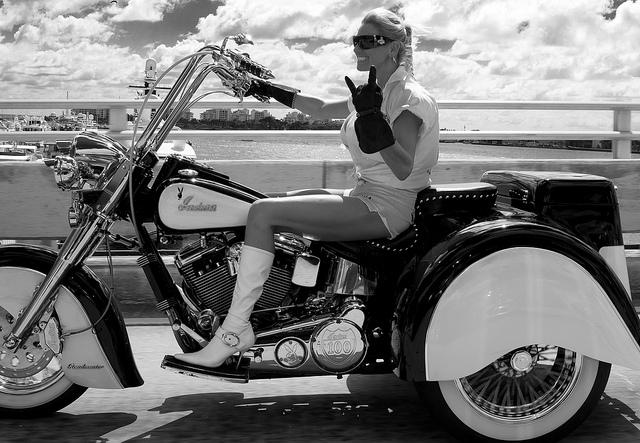How many fingers is she holding up?
Be succinct. 2. What is on the top left of the photo?
Short answer required. Clouds. Is the woman a motorcyclist?
Be succinct. Yes. Who is riding the motorcycle?
Write a very short answer. Woman. 